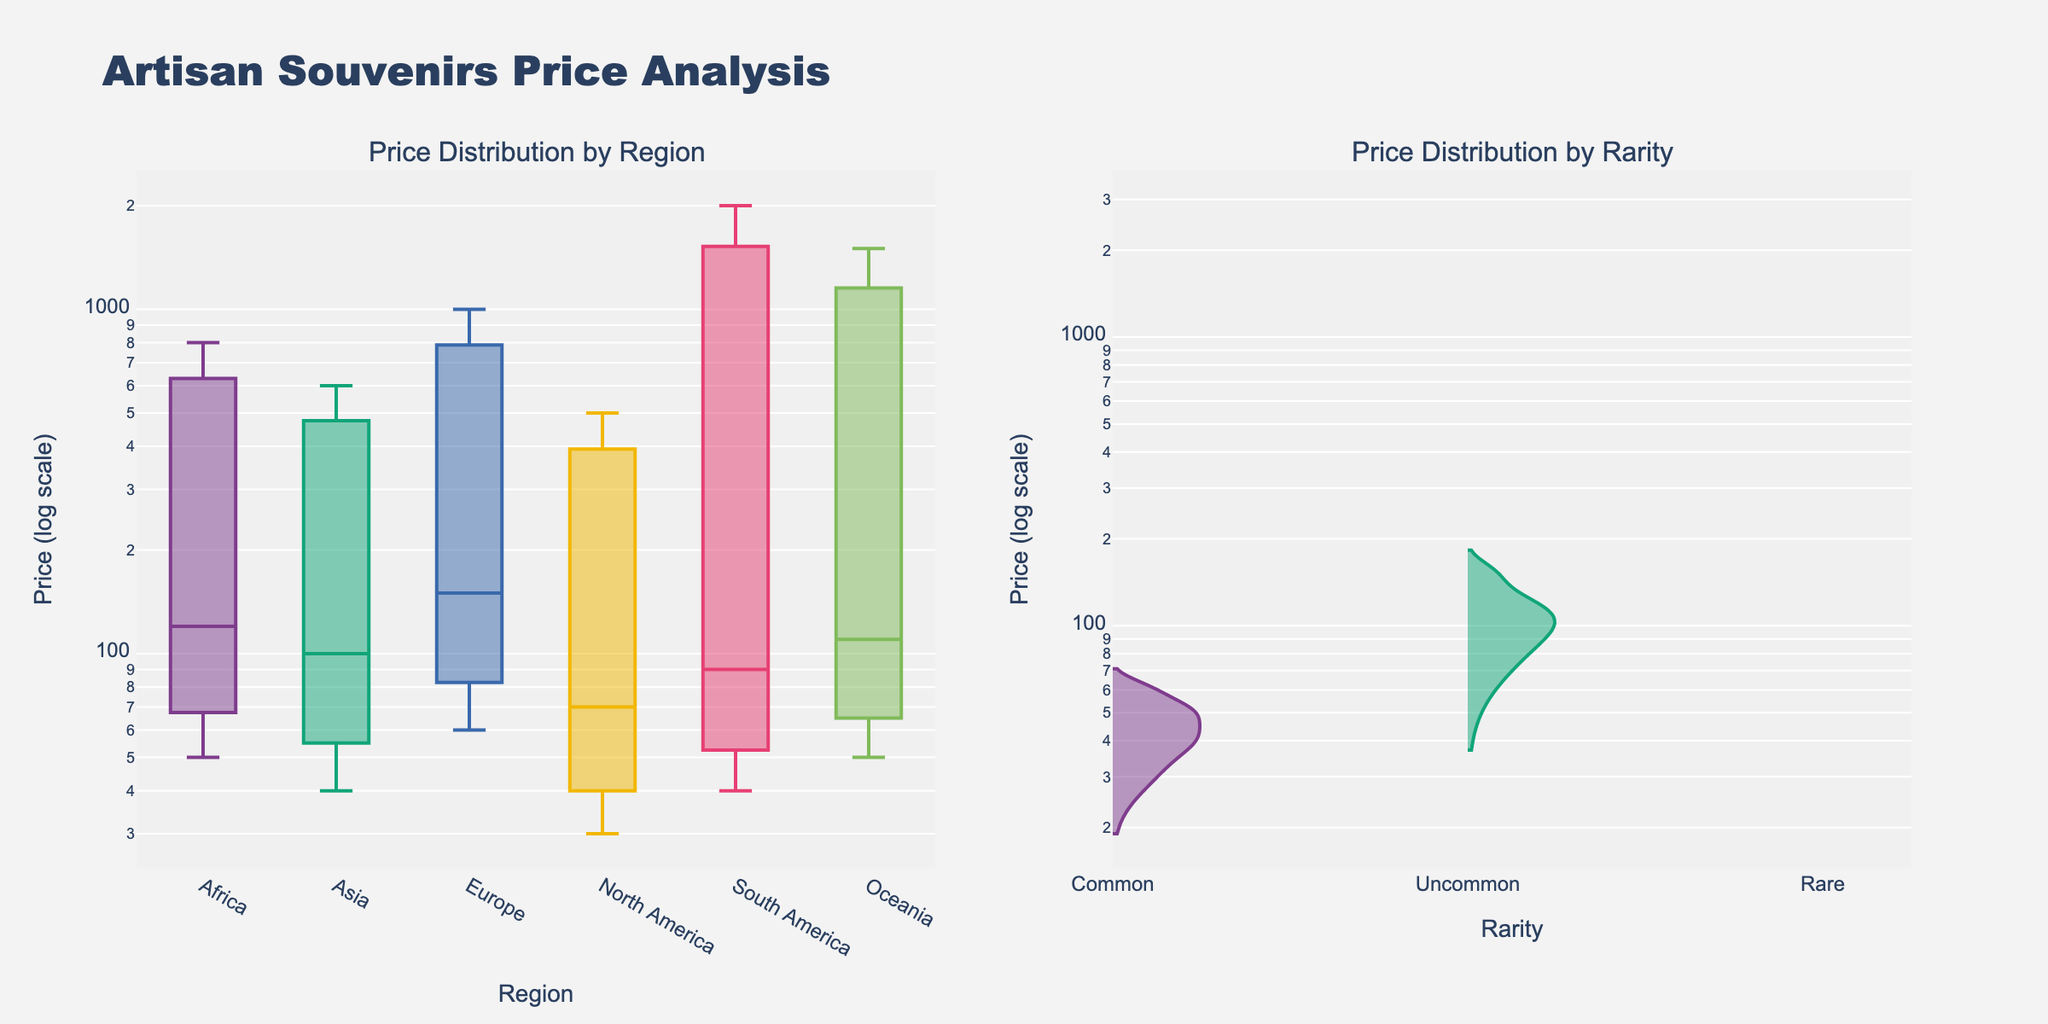What is the title of the figure? The title is usually displayed at the top of the figure. In this case, it is "Artisan Souvenirs Price Analysis."
Answer: Artisan Souvenirs Price Analysis What are the y-axis labels for both subplots? The y-axis for both subplots is labeled "Price (log scale)." This is specified in the y-axis title.
Answer: Price (log scale) Which region has the highest range of prices? To find the region with the highest range of prices, look for the box plot with the largest span on the y-axis. This would be the Europe region, ranging from around 60 to 1000 on the log scale.
Answer: Europe Which rarity category has the lowest average price? Observe the center of the violin plots for each rarity category. The 'Common' category has a lower average price compared to 'Uncommon' and 'Rare'.
Answer: Common How do prices generally change with rarity? By observing the violin plots, we see that as the rarity changes from 'Common' to 'Rare', the average price increases significantly.
Answer: Prices increase with rarity Which region has the most expensive item, and what is its price? Look for the highest point in the box plot of each region. For Europe, the highest price is close to 1000 (log scale), which is the highest amongst all regions.
Answer: Europe, 1000 How does the distribution of prices in Asia compare to that in Oceania? The box plot for Asia shows a narrower range and lower median compared to Oceania. Oceania has a wider range indicating more price variation.
Answer: Oceania has a wider range and higher prices Which rarity category shows the greatest variability in prices? In the violin plots, the 'Rare' category has the widest spread, indicating the greatest variability in prices.
Answer: Rare Compare the median prices of items from North America and South America. The medians in the box plots are the central lines inside the boxes. North America has a lower median price compared to South America.
Answer: North America has a lower median price Which region has the lowest minimum price? Identify the lowest point on the box plots for each region. North America shows the lowest minimum price at around 30 (log scale).
Answer: North America 